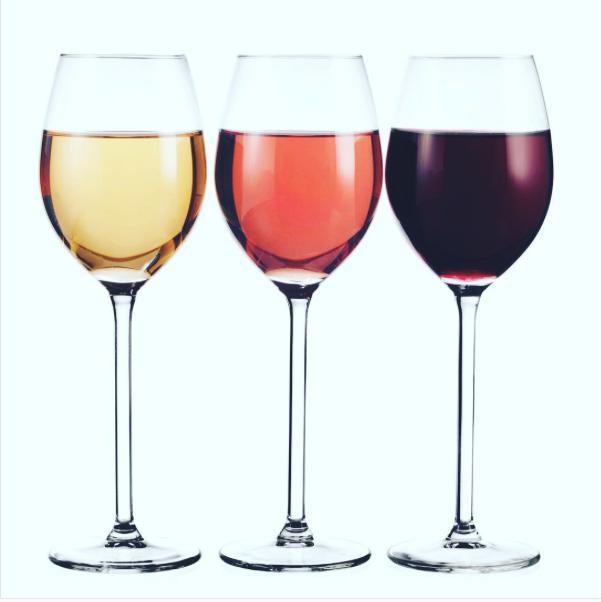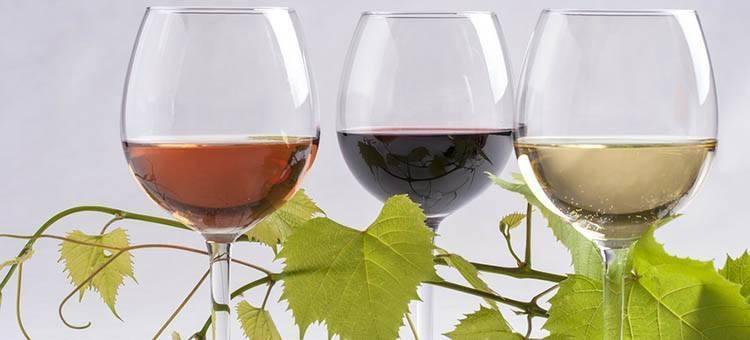The first image is the image on the left, the second image is the image on the right. Evaluate the accuracy of this statement regarding the images: "Each image shows exactly three wine glasses, which contain different colors of wine.". Is it true? Answer yes or no. Yes. The first image is the image on the left, the second image is the image on the right. Considering the images on both sides, is "The wine glass furthest to the right in the right image contains dark red liquid." valid? Answer yes or no. No. 